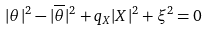Convert formula to latex. <formula><loc_0><loc_0><loc_500><loc_500>| \theta | ^ { 2 } - | \overline { \theta } | ^ { 2 } + q _ { X } | X | ^ { 2 } + \xi ^ { 2 } = 0</formula> 